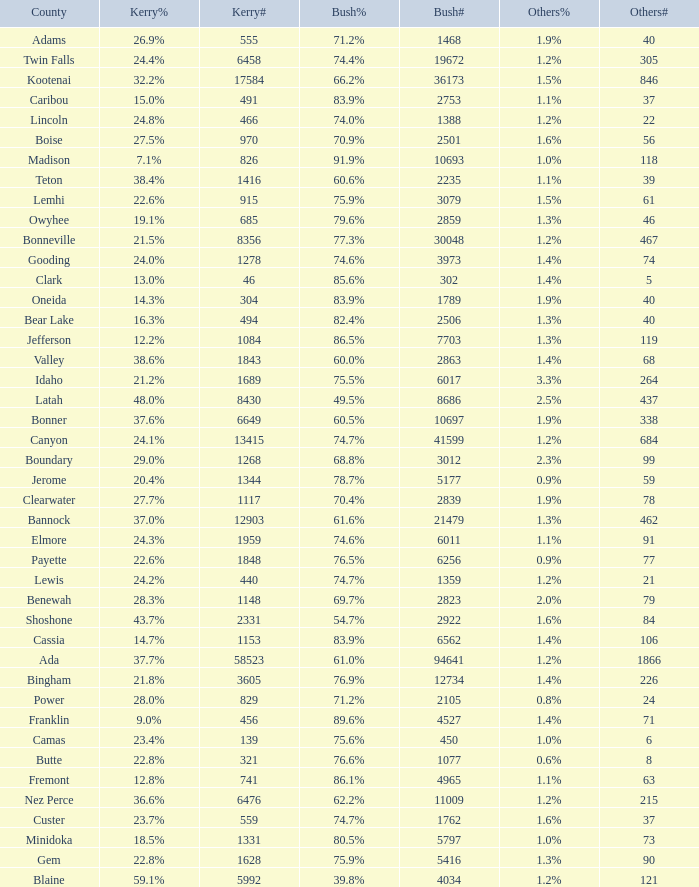What percentage of the people in Bonneville voted for Bush? 77.3%. Parse the full table. {'header': ['County', 'Kerry%', 'Kerry#', 'Bush%', 'Bush#', 'Others%', 'Others#'], 'rows': [['Adams', '26.9%', '555', '71.2%', '1468', '1.9%', '40'], ['Twin Falls', '24.4%', '6458', '74.4%', '19672', '1.2%', '305'], ['Kootenai', '32.2%', '17584', '66.2%', '36173', '1.5%', '846'], ['Caribou', '15.0%', '491', '83.9%', '2753', '1.1%', '37'], ['Lincoln', '24.8%', '466', '74.0%', '1388', '1.2%', '22'], ['Boise', '27.5%', '970', '70.9%', '2501', '1.6%', '56'], ['Madison', '7.1%', '826', '91.9%', '10693', '1.0%', '118'], ['Teton', '38.4%', '1416', '60.6%', '2235', '1.1%', '39'], ['Lemhi', '22.6%', '915', '75.9%', '3079', '1.5%', '61'], ['Owyhee', '19.1%', '685', '79.6%', '2859', '1.3%', '46'], ['Bonneville', '21.5%', '8356', '77.3%', '30048', '1.2%', '467'], ['Gooding', '24.0%', '1278', '74.6%', '3973', '1.4%', '74'], ['Clark', '13.0%', '46', '85.6%', '302', '1.4%', '5'], ['Oneida', '14.3%', '304', '83.9%', '1789', '1.9%', '40'], ['Bear Lake', '16.3%', '494', '82.4%', '2506', '1.3%', '40'], ['Jefferson', '12.2%', '1084', '86.5%', '7703', '1.3%', '119'], ['Valley', '38.6%', '1843', '60.0%', '2863', '1.4%', '68'], ['Idaho', '21.2%', '1689', '75.5%', '6017', '3.3%', '264'], ['Latah', '48.0%', '8430', '49.5%', '8686', '2.5%', '437'], ['Bonner', '37.6%', '6649', '60.5%', '10697', '1.9%', '338'], ['Canyon', '24.1%', '13415', '74.7%', '41599', '1.2%', '684'], ['Boundary', '29.0%', '1268', '68.8%', '3012', '2.3%', '99'], ['Jerome', '20.4%', '1344', '78.7%', '5177', '0.9%', '59'], ['Clearwater', '27.7%', '1117', '70.4%', '2839', '1.9%', '78'], ['Bannock', '37.0%', '12903', '61.6%', '21479', '1.3%', '462'], ['Elmore', '24.3%', '1959', '74.6%', '6011', '1.1%', '91'], ['Payette', '22.6%', '1848', '76.5%', '6256', '0.9%', '77'], ['Lewis', '24.2%', '440', '74.7%', '1359', '1.2%', '21'], ['Benewah', '28.3%', '1148', '69.7%', '2823', '2.0%', '79'], ['Shoshone', '43.7%', '2331', '54.7%', '2922', '1.6%', '84'], ['Cassia', '14.7%', '1153', '83.9%', '6562', '1.4%', '106'], ['Ada', '37.7%', '58523', '61.0%', '94641', '1.2%', '1866'], ['Bingham', '21.8%', '3605', '76.9%', '12734', '1.4%', '226'], ['Power', '28.0%', '829', '71.2%', '2105', '0.8%', '24'], ['Franklin', '9.0%', '456', '89.6%', '4527', '1.4%', '71'], ['Camas', '23.4%', '139', '75.6%', '450', '1.0%', '6'], ['Butte', '22.8%', '321', '76.6%', '1077', '0.6%', '8'], ['Fremont', '12.8%', '741', '86.1%', '4965', '1.1%', '63'], ['Nez Perce', '36.6%', '6476', '62.2%', '11009', '1.2%', '215'], ['Custer', '23.7%', '559', '74.7%', '1762', '1.6%', '37'], ['Minidoka', '18.5%', '1331', '80.5%', '5797', '1.0%', '73'], ['Gem', '22.8%', '1628', '75.9%', '5416', '1.3%', '90'], ['Blaine', '59.1%', '5992', '39.8%', '4034', '1.2%', '121']]} 